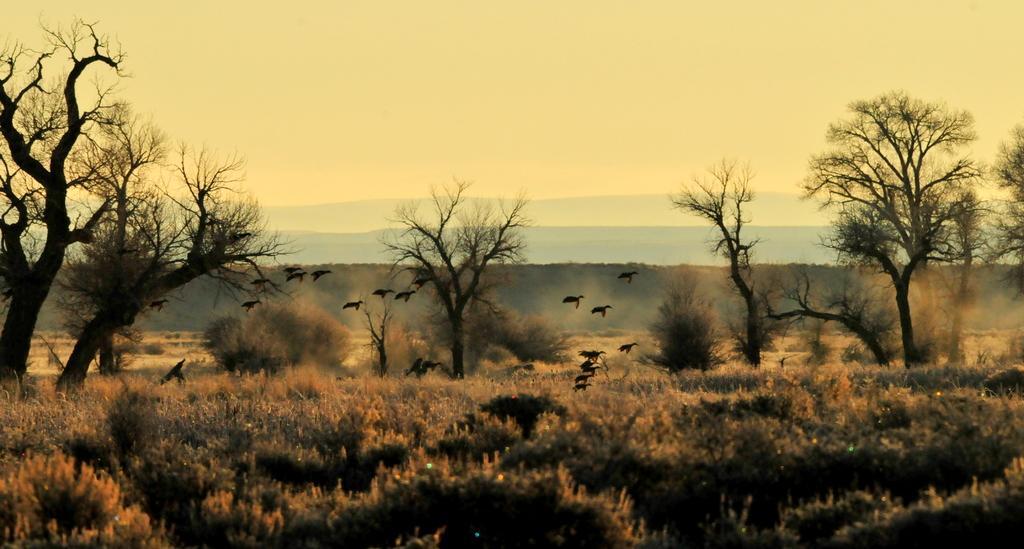Can you describe this image briefly? At the bottom of this image, there are plants and trees on the ground. Above these plants, there are birds. Some of these birds are flying in the air. In the background, there are mountains and there are clouds in the sky. 